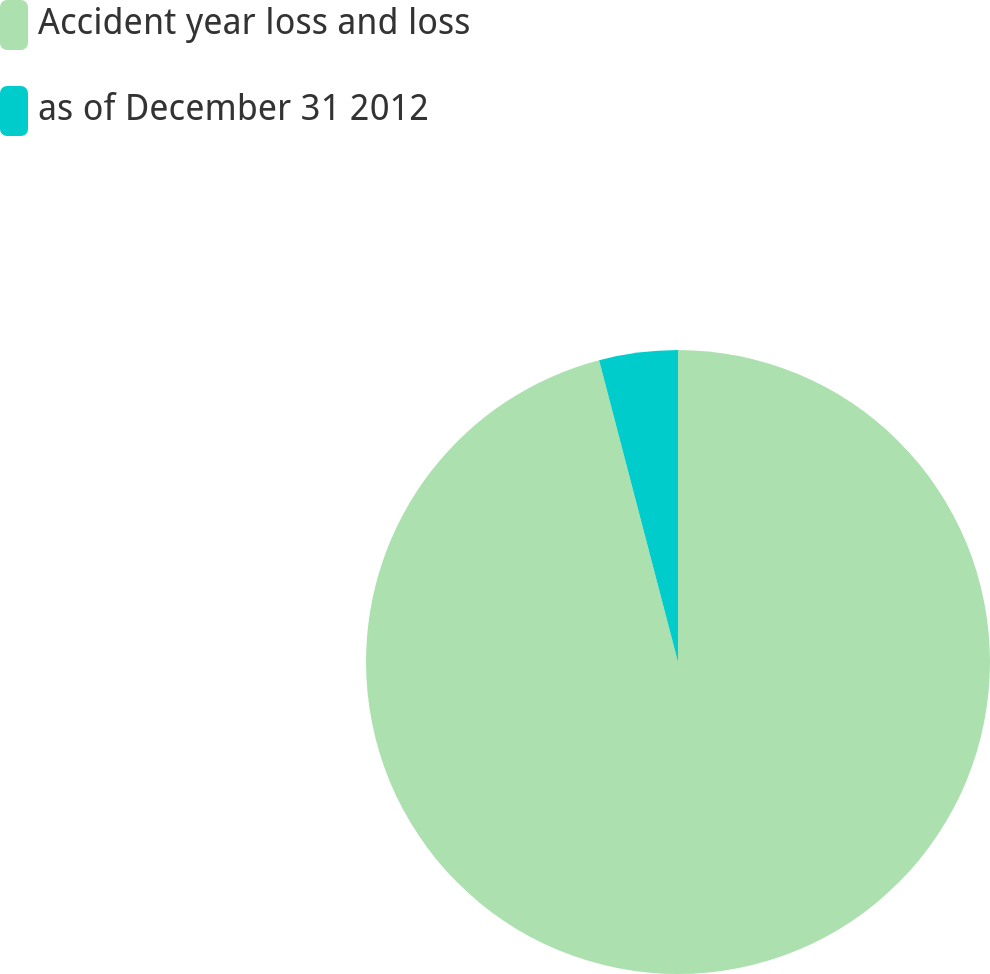Convert chart. <chart><loc_0><loc_0><loc_500><loc_500><pie_chart><fcel>Accident year loss and loss<fcel>as of December 31 2012<nl><fcel>95.93%<fcel>4.07%<nl></chart> 